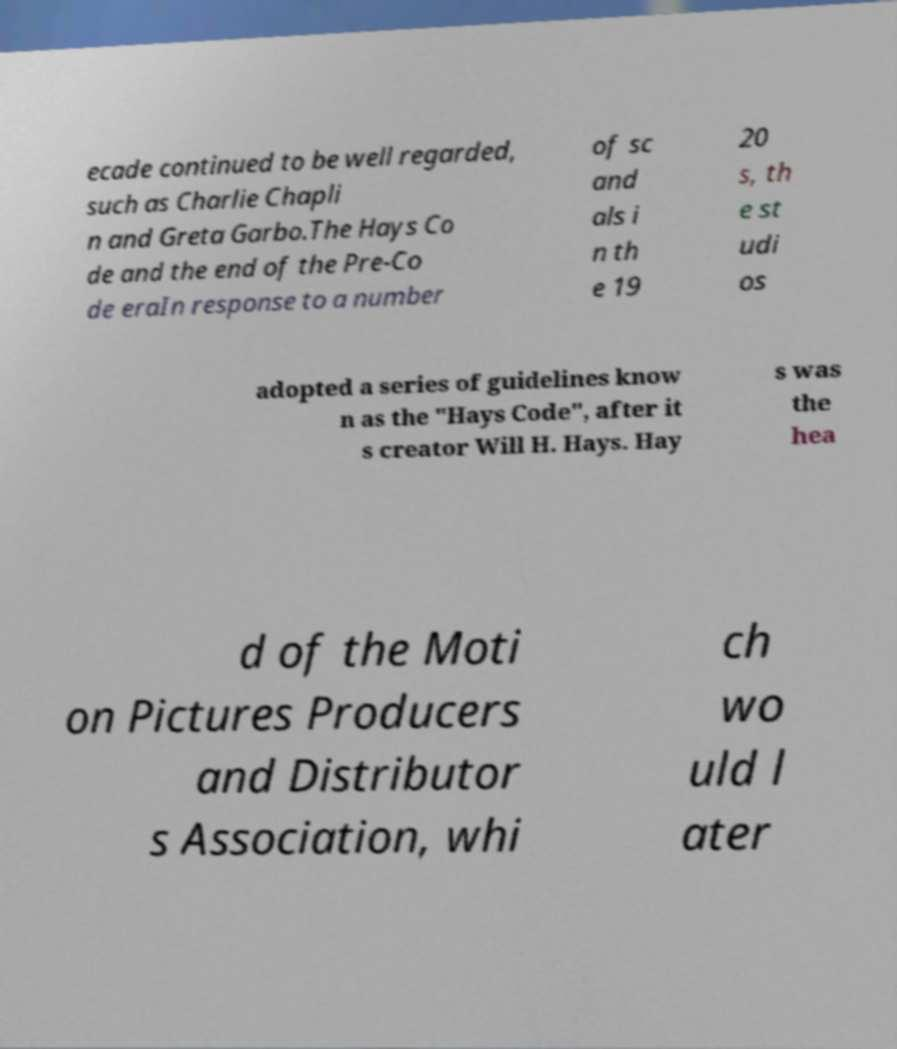Please identify and transcribe the text found in this image. ecade continued to be well regarded, such as Charlie Chapli n and Greta Garbo.The Hays Co de and the end of the Pre-Co de eraIn response to a number of sc and als i n th e 19 20 s, th e st udi os adopted a series of guidelines know n as the "Hays Code", after it s creator Will H. Hays. Hay s was the hea d of the Moti on Pictures Producers and Distributor s Association, whi ch wo uld l ater 